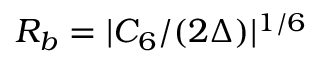<formula> <loc_0><loc_0><loc_500><loc_500>R _ { b } = | C _ { 6 } / ( 2 \Delta ) | ^ { 1 / 6 }</formula> 